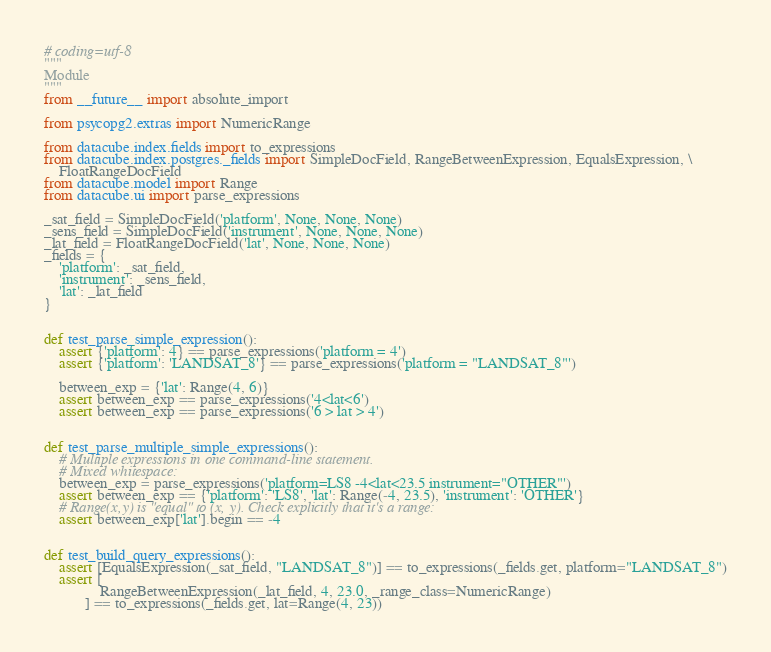<code> <loc_0><loc_0><loc_500><loc_500><_Python_># coding=utf-8
"""
Module
"""
from __future__ import absolute_import

from psycopg2.extras import NumericRange

from datacube.index.fields import to_expressions
from datacube.index.postgres._fields import SimpleDocField, RangeBetweenExpression, EqualsExpression, \
    FloatRangeDocField
from datacube.model import Range
from datacube.ui import parse_expressions

_sat_field = SimpleDocField('platform', None, None, None)
_sens_field = SimpleDocField('instrument', None, None, None)
_lat_field = FloatRangeDocField('lat', None, None, None)
_fields = {
    'platform': _sat_field,
    'instrument': _sens_field,
    'lat': _lat_field
}


def test_parse_simple_expression():
    assert {'platform': 4} == parse_expressions('platform = 4')
    assert {'platform': 'LANDSAT_8'} == parse_expressions('platform = "LANDSAT_8"')

    between_exp = {'lat': Range(4, 6)}
    assert between_exp == parse_expressions('4<lat<6')
    assert between_exp == parse_expressions('6 > lat > 4')


def test_parse_multiple_simple_expressions():
    # Multiple expressions in one command-line statement.
    # Mixed whitespace:
    between_exp = parse_expressions('platform=LS8 -4<lat<23.5 instrument="OTHER"')
    assert between_exp == {'platform': 'LS8', 'lat': Range(-4, 23.5), 'instrument': 'OTHER'}
    # Range(x,y) is "equal" to (x, y). Check explicitly that it's a range:
    assert between_exp['lat'].begin == -4


def test_build_query_expressions():
    assert [EqualsExpression(_sat_field, "LANDSAT_8")] == to_expressions(_fields.get, platform="LANDSAT_8")
    assert [
               RangeBetweenExpression(_lat_field, 4, 23.0, _range_class=NumericRange)
           ] == to_expressions(_fields.get, lat=Range(4, 23))
</code> 